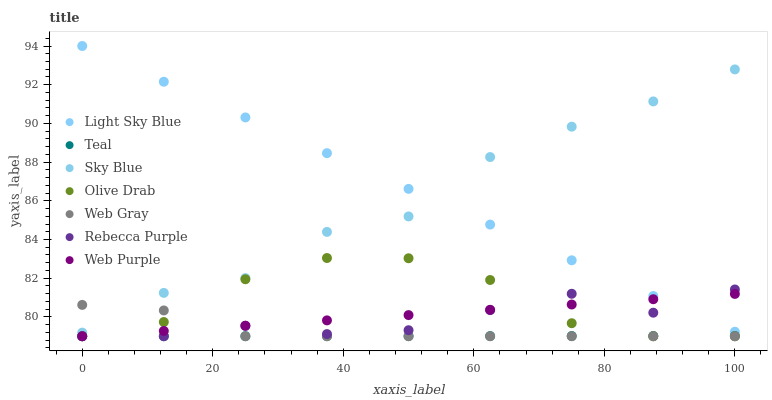Does Teal have the minimum area under the curve?
Answer yes or no. Yes. Does Light Sky Blue have the maximum area under the curve?
Answer yes or no. Yes. Does Web Purple have the minimum area under the curve?
Answer yes or no. No. Does Web Purple have the maximum area under the curve?
Answer yes or no. No. Is Teal the smoothest?
Answer yes or no. Yes. Is Sky Blue the roughest?
Answer yes or no. Yes. Is Web Purple the smoothest?
Answer yes or no. No. Is Web Purple the roughest?
Answer yes or no. No. Does Web Gray have the lowest value?
Answer yes or no. Yes. Does Light Sky Blue have the lowest value?
Answer yes or no. No. Does Light Sky Blue have the highest value?
Answer yes or no. Yes. Does Web Purple have the highest value?
Answer yes or no. No. Is Web Purple less than Sky Blue?
Answer yes or no. Yes. Is Sky Blue greater than Rebecca Purple?
Answer yes or no. Yes. Does Olive Drab intersect Teal?
Answer yes or no. Yes. Is Olive Drab less than Teal?
Answer yes or no. No. Is Olive Drab greater than Teal?
Answer yes or no. No. Does Web Purple intersect Sky Blue?
Answer yes or no. No. 